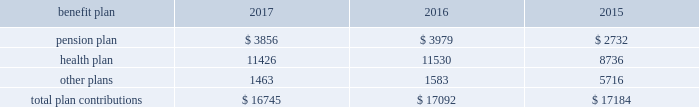112 / sl green realty corp .
2017 annual report 20 .
Commitments and contingencies legal proceedings as of december a031 , 2017 , the company and the operating partnership were not involved in any material litigation nor , to management 2019s knowledge , was any material litigation threat- ened against us or our portfolio which if adversely determined could have a material adverse impact on us .
Environmental matters our management believes that the properties are in compliance in all material respects with applicable federal , state and local ordinances and regulations regarding environmental issues .
Management is not aware of any environmental liability that it believes would have a materially adverse impact on our financial position , results of operations or cash flows .
Management is unaware of any instances in which it would incur significant envi- ronmental cost if any of our properties were sold .
Employment agreements we have entered into employment agreements with certain exec- utives , which expire between december a02018 and february a02020 .
The minimum cash-based compensation , including base sal- ary and guaranteed bonus payments , associated with these employment agreements total $ 5.4 a0million for 2018 .
In addition these employment agreements provide for deferred compen- sation awards based on our stock price and which were valued at $ 1.6 a0million on the grant date .
The value of these awards may change based on fluctuations in our stock price .
Insurance we maintain 201call-risk 201d property and rental value coverage ( includ- ing coverage regarding the perils of flood , earthquake and terrorism , excluding nuclear , biological , chemical , and radiological terrorism ( 201cnbcr 201d ) ) , within three property insurance programs and liability insurance .
Separate property and liability coverage may be purchased on a stand-alone basis for certain assets , such as the development of one vanderbilt .
Additionally , our captive insurance company , belmont insurance company , or belmont , pro- vides coverage for nbcr terrorist acts above a specified trigger , although if belmont is required to pay a claim under our insur- ance policies , we would ultimately record the loss to the extent of belmont 2019s required payment .
However , there is no assurance that in the future we will be able to procure coverage at a reasonable cost .
Further , if we experience losses that are uninsured or that exceed policy limits , we could lose the capital invested in the damaged properties as well as the anticipated future cash flows from those plan trustees adopted a rehabilitation plan consistent with this requirement .
No surcharges have been paid to the pension plan as of december a031 , 2017 .
For the pension plan years ended june a030 , 2017 , 2016 , and 2015 , the plan received contributions from employers totaling $ 257.8 a0million , $ 249.5 a0million , and $ 221.9 a0million .
Our contributions to the pension plan represent less than 5.0% ( 5.0 % ) of total contributions to the plan .
The health plan was established under the terms of collective bargaining agreements between the union , the realty advisory board on labor relations , inc .
And certain other employees .
The health plan provides health and other benefits to eligible participants employed in the building service industry who are covered under collective bargaining agreements , or other writ- ten agreements , with the union .
The health plan is administered by a board of trustees with equal representation by the employ- ers and the union and operates under employer identification number a013-2928869 .
The health plan receives contributions in accordance with collective bargaining agreements or participa- tion agreements .
Generally , these agreements provide that the employers contribute to the health plan at a fixed rate on behalf of each covered employee .
For the health plan years ended , june a030 , 2017 , 2016 , and 2015 , the plan received contributions from employers totaling $ 1.3 a0billion , $ 1.2 a0billion and $ 1.1 a0billion , respectively .
Our contributions to the health plan represent less than 5.0% ( 5.0 % ) of total contributions to the plan .
Contributions we made to the multi-employer plans for the years ended december a031 , 2017 , 2016 and 2015 are included in the table below ( in thousands ) : .
401 ( k ) plan in august a01997 , we implemented a 401 ( k ) a0savings/retirement plan , or the 401 ( k ) a0plan , to cover eligible employees of ours , and any designated affiliate .
The 401 ( k ) a0plan permits eligible employees to defer up to 15% ( 15 % ) of their annual compensation , subject to certain limitations imposed by the code .
The employees 2019 elective deferrals are immediately vested and non-forfeitable upon contribution to the 401 ( k ) a0plan .
During a02003 , we amended our 401 ( k ) a0plan to pro- vide for discretionary matching contributions only .
For 2017 , 2016 and 2015 , a matching contribution equal to 50% ( 50 % ) of the first 6% ( 6 % ) of annual compensation was made .
For the year ended december a031 , 2017 , we made a matching contribution of $ 728782 .
For the years ended december a031 , 2016 and 2015 , we made matching contribu- tions of $ 566000 and $ 550000 , respectively. .
What was the percentage increase in the pension plan contributions from 2015 to 2016? 
Computations: ((249.5 - 221.9) / 221.9)
Answer: 0.12438. 112 / sl green realty corp .
2017 annual report 20 .
Commitments and contingencies legal proceedings as of december a031 , 2017 , the company and the operating partnership were not involved in any material litigation nor , to management 2019s knowledge , was any material litigation threat- ened against us or our portfolio which if adversely determined could have a material adverse impact on us .
Environmental matters our management believes that the properties are in compliance in all material respects with applicable federal , state and local ordinances and regulations regarding environmental issues .
Management is not aware of any environmental liability that it believes would have a materially adverse impact on our financial position , results of operations or cash flows .
Management is unaware of any instances in which it would incur significant envi- ronmental cost if any of our properties were sold .
Employment agreements we have entered into employment agreements with certain exec- utives , which expire between december a02018 and february a02020 .
The minimum cash-based compensation , including base sal- ary and guaranteed bonus payments , associated with these employment agreements total $ 5.4 a0million for 2018 .
In addition these employment agreements provide for deferred compen- sation awards based on our stock price and which were valued at $ 1.6 a0million on the grant date .
The value of these awards may change based on fluctuations in our stock price .
Insurance we maintain 201call-risk 201d property and rental value coverage ( includ- ing coverage regarding the perils of flood , earthquake and terrorism , excluding nuclear , biological , chemical , and radiological terrorism ( 201cnbcr 201d ) ) , within three property insurance programs and liability insurance .
Separate property and liability coverage may be purchased on a stand-alone basis for certain assets , such as the development of one vanderbilt .
Additionally , our captive insurance company , belmont insurance company , or belmont , pro- vides coverage for nbcr terrorist acts above a specified trigger , although if belmont is required to pay a claim under our insur- ance policies , we would ultimately record the loss to the extent of belmont 2019s required payment .
However , there is no assurance that in the future we will be able to procure coverage at a reasonable cost .
Further , if we experience losses that are uninsured or that exceed policy limits , we could lose the capital invested in the damaged properties as well as the anticipated future cash flows from those plan trustees adopted a rehabilitation plan consistent with this requirement .
No surcharges have been paid to the pension plan as of december a031 , 2017 .
For the pension plan years ended june a030 , 2017 , 2016 , and 2015 , the plan received contributions from employers totaling $ 257.8 a0million , $ 249.5 a0million , and $ 221.9 a0million .
Our contributions to the pension plan represent less than 5.0% ( 5.0 % ) of total contributions to the plan .
The health plan was established under the terms of collective bargaining agreements between the union , the realty advisory board on labor relations , inc .
And certain other employees .
The health plan provides health and other benefits to eligible participants employed in the building service industry who are covered under collective bargaining agreements , or other writ- ten agreements , with the union .
The health plan is administered by a board of trustees with equal representation by the employ- ers and the union and operates under employer identification number a013-2928869 .
The health plan receives contributions in accordance with collective bargaining agreements or participa- tion agreements .
Generally , these agreements provide that the employers contribute to the health plan at a fixed rate on behalf of each covered employee .
For the health plan years ended , june a030 , 2017 , 2016 , and 2015 , the plan received contributions from employers totaling $ 1.3 a0billion , $ 1.2 a0billion and $ 1.1 a0billion , respectively .
Our contributions to the health plan represent less than 5.0% ( 5.0 % ) of total contributions to the plan .
Contributions we made to the multi-employer plans for the years ended december a031 , 2017 , 2016 and 2015 are included in the table below ( in thousands ) : .
401 ( k ) plan in august a01997 , we implemented a 401 ( k ) a0savings/retirement plan , or the 401 ( k ) a0plan , to cover eligible employees of ours , and any designated affiliate .
The 401 ( k ) a0plan permits eligible employees to defer up to 15% ( 15 % ) of their annual compensation , subject to certain limitations imposed by the code .
The employees 2019 elective deferrals are immediately vested and non-forfeitable upon contribution to the 401 ( k ) a0plan .
During a02003 , we amended our 401 ( k ) a0plan to pro- vide for discretionary matching contributions only .
For 2017 , 2016 and 2015 , a matching contribution equal to 50% ( 50 % ) of the first 6% ( 6 % ) of annual compensation was made .
For the year ended december a031 , 2017 , we made a matching contribution of $ 728782 .
For the years ended december a031 , 2016 and 2015 , we made matching contribu- tions of $ 566000 and $ 550000 , respectively. .
What percentage of total contributions in 2017 was the 2017 pension plan? 
Computations: ((3856 / 16745) * 100)
Answer: 23.02777. 